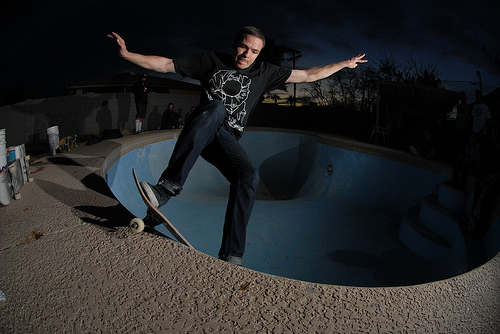Can you tell me more about the setting of this image? Certainly! The image shows an outdoor setting during twilight or nighttime, evident by the dark sky. The location includes an empty pool commonly used by skateboarders to perform tricks. There are elements in the background that suggest a residential area, such as a fence and what might be a part of a house or shed. What time of day does the lighting suggest? The lighting in the image, especially the long shadows and the artificial light source on the left, suggests it is either early evening or night, with additional lighting set up to illuminate the pool area for visibility. 